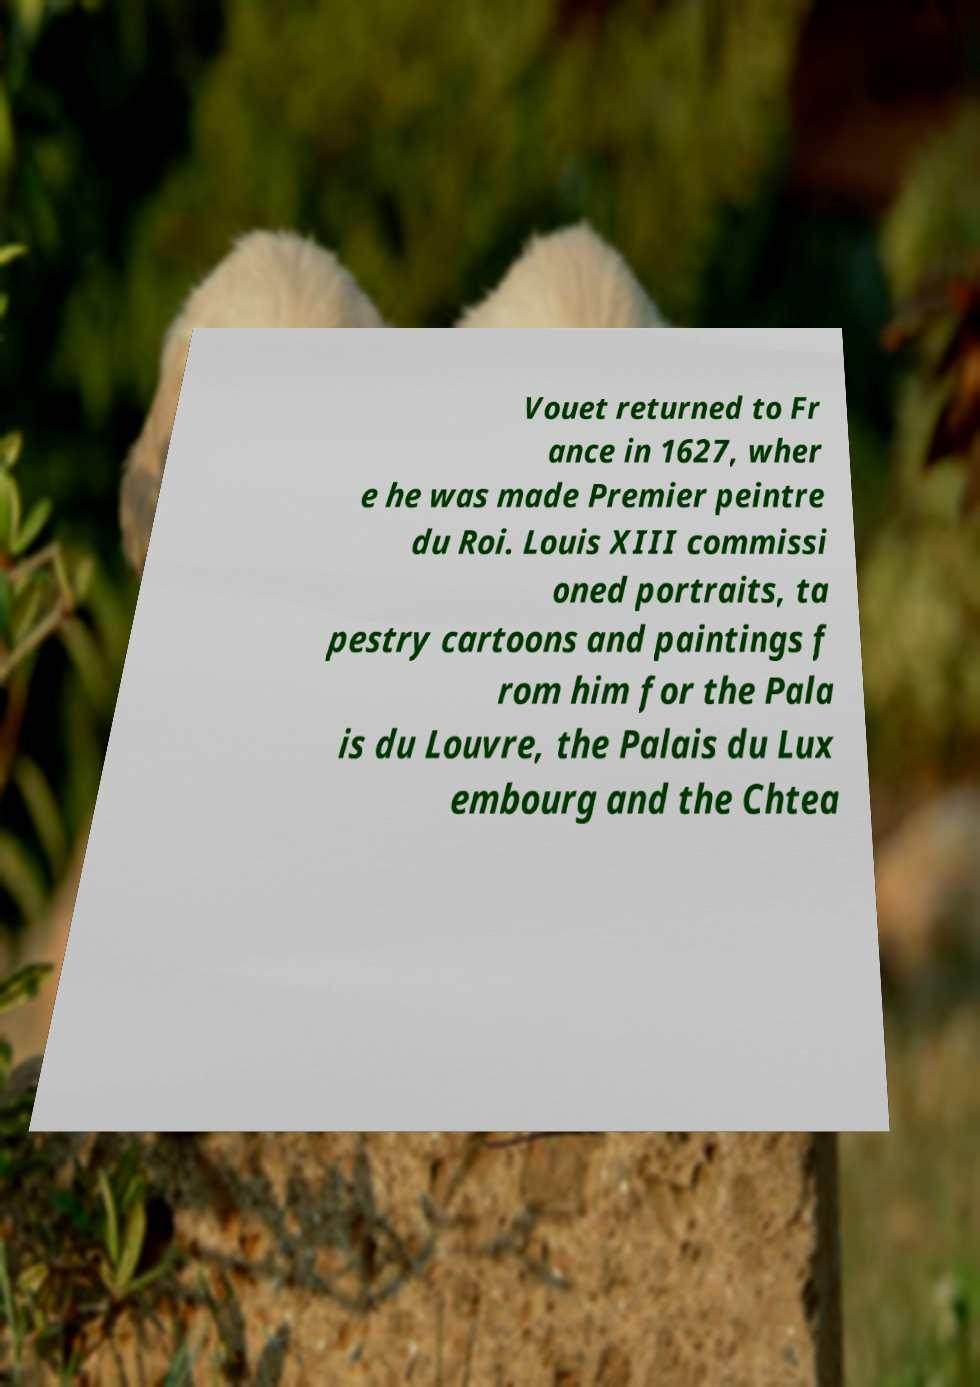For documentation purposes, I need the text within this image transcribed. Could you provide that? Vouet returned to Fr ance in 1627, wher e he was made Premier peintre du Roi. Louis XIII commissi oned portraits, ta pestry cartoons and paintings f rom him for the Pala is du Louvre, the Palais du Lux embourg and the Chtea 